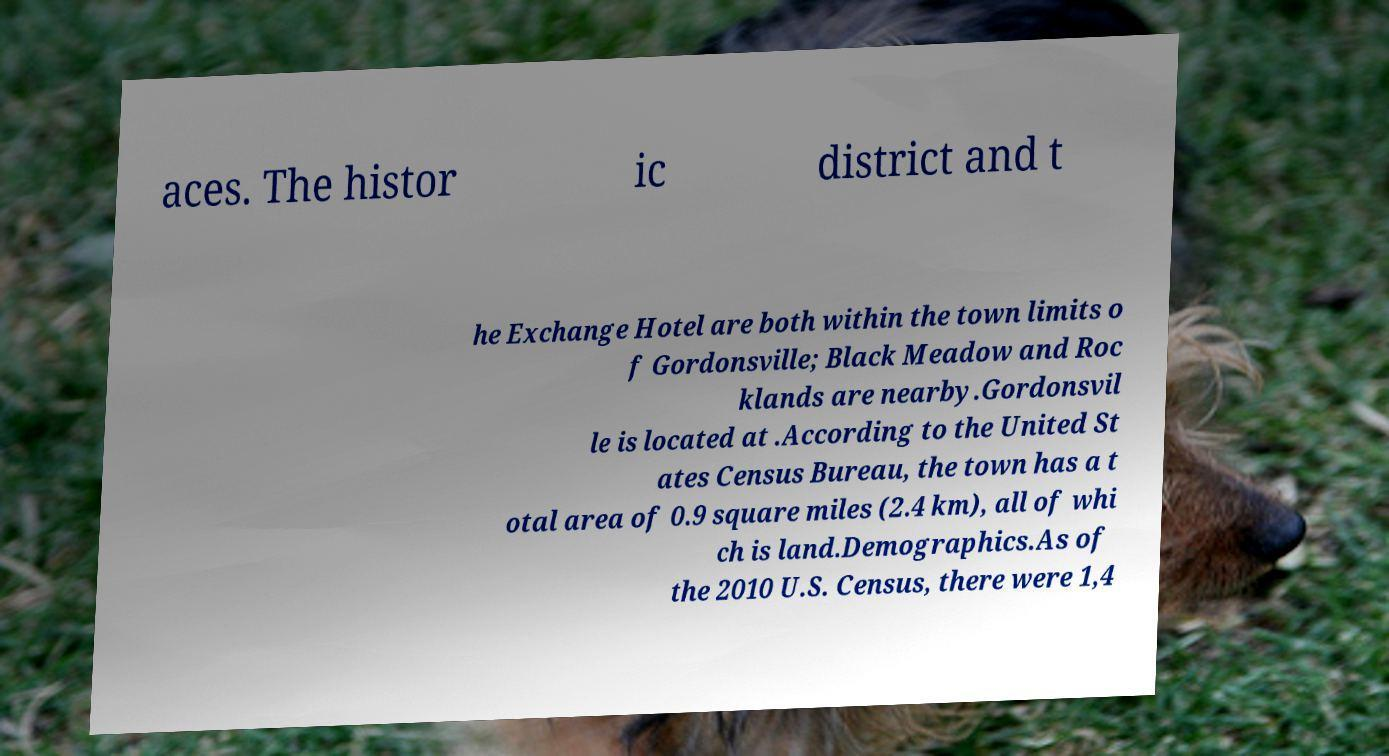I need the written content from this picture converted into text. Can you do that? aces. The histor ic district and t he Exchange Hotel are both within the town limits o f Gordonsville; Black Meadow and Roc klands are nearby.Gordonsvil le is located at .According to the United St ates Census Bureau, the town has a t otal area of 0.9 square miles (2.4 km), all of whi ch is land.Demographics.As of the 2010 U.S. Census, there were 1,4 